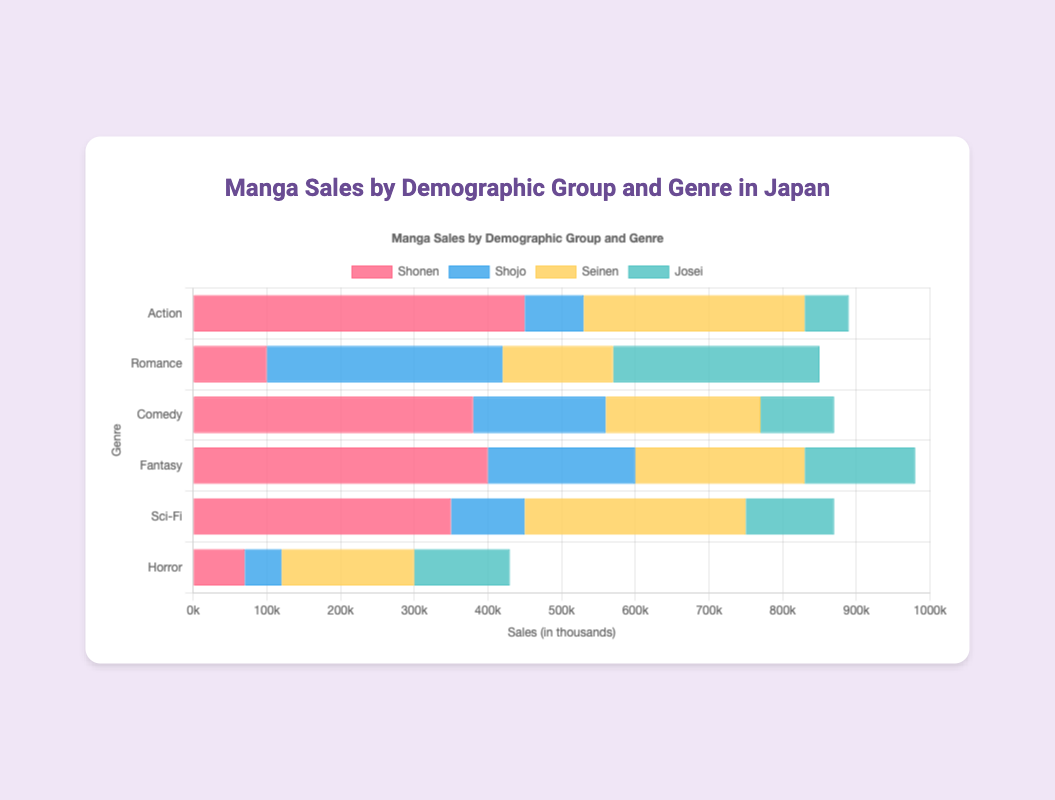Which genre has the highest sales in the Shonen demographic? Look at the bars representing the Shonen demographic. The Action genre has the tallest bar, indicating it has the highest sales for Shonen.
Answer: Action Which genre has the lowest sales in the Josei demographic? Examine the bars for the Josei demographic. The Action genre has the shortest bar, showing it has the lowest sales for Josei.
Answer: Action What is the total sales for the Romance genre across all demographics? Sum the sales figures for the Romance genre in all demographic groups: 100,000 (Shonen) + 320,000 (Shojo) + 150,000 (Seinen) + 280,000 (Josei).
Answer: 850,000 Compare the total sales for Comedy and Fantasy, which one is higher? Sum the sales for both genres across all demographics. Comedy: 380,000 + 180,000 + 210,000 + 100,000 = 870,000. Fantasy: 400,000 + 200,000 + 230,000 + 150,000 = 980,000.
Answer: Fantasy Which demographic has the highest total sales for all genres combined? Add up the sales figures for each demographic across all genres and compare: Shonen (450,000+100,000+380,000+400,000+350,000+70,000), Shojo (80,000+320,000+180,000+200,000+100,000+50,000), Seinen (300,000+150,000+210,000+230,000+300,000+180,000), Josei (60,000+280,000+100,000+150,000+120,000+130,000).
Answer: Shonen What is the difference in sales between the highest and lowest selling genres in the Seinen demographic? Identify the highest and lowest sales in Seinen: Highest (Action) = 300,000, Lowest (Horror) = 180,000. Calculate the difference: 300,000 - 180,000.
Answer: 120,000 Compare the sales of Sci-Fi in the Shojo and Seinen demographics. Which one is higher? Look at the bars for Sci-Fi genre in Shojo and Seinen demographics: Shojo = 100,000, Seinen = 300,000.
Answer: Seinen What's the sum of sales for the Horror genre in the Shonen and Shojo demographics? Add the sales figures for Horror in Shonen and Shojo: 70,000 + 50,000.
Answer: 120,000 Is the amount of sales for Fantasy in the Shonen demographic greater than the sales for Comedy in the Seinen demographic? Compare the sales figures: Fantasy in Shonen = 400,000, Comedy in Seinen = 210,000.
Answer: Yes 